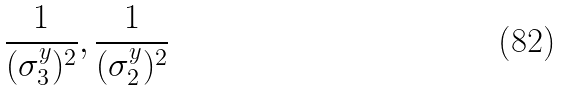Convert formula to latex. <formula><loc_0><loc_0><loc_500><loc_500>\frac { 1 } { ( \sigma _ { 3 } ^ { y } ) ^ { 2 } } , \frac { 1 } { ( \sigma _ { 2 } ^ { y } ) ^ { 2 } }</formula> 